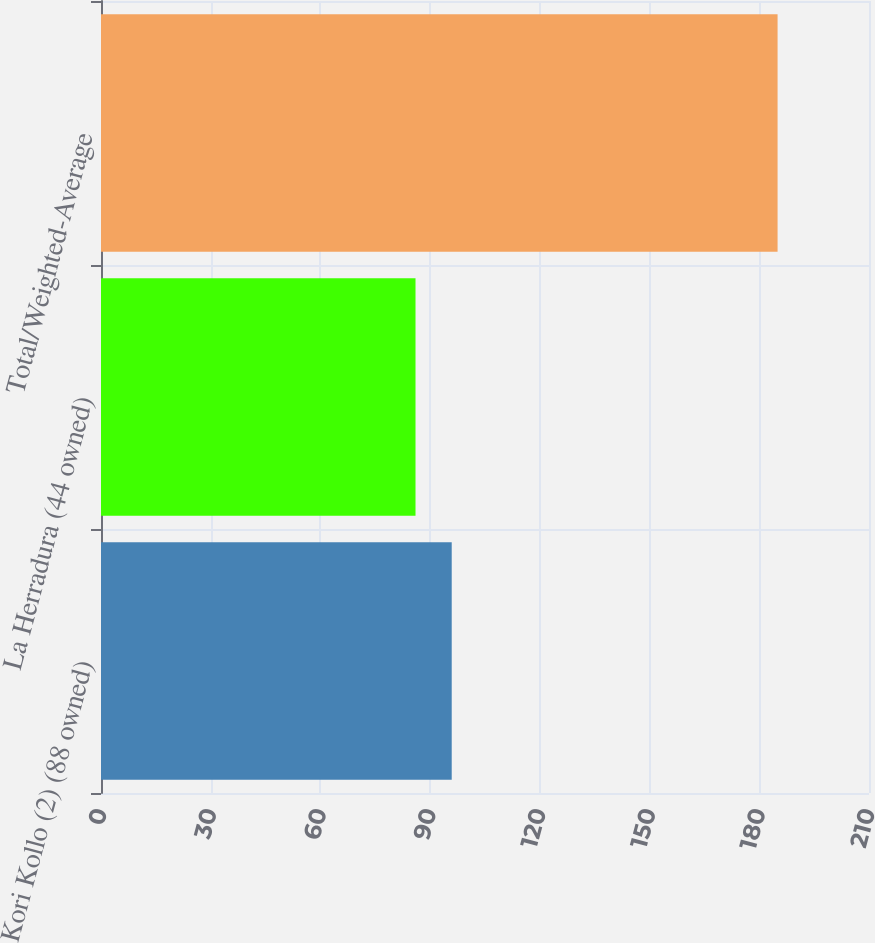<chart> <loc_0><loc_0><loc_500><loc_500><bar_chart><fcel>Kori Kollo (2) (88 owned)<fcel>La Herradura (44 owned)<fcel>Total/Weighted-Average<nl><fcel>95.9<fcel>86<fcel>185<nl></chart> 